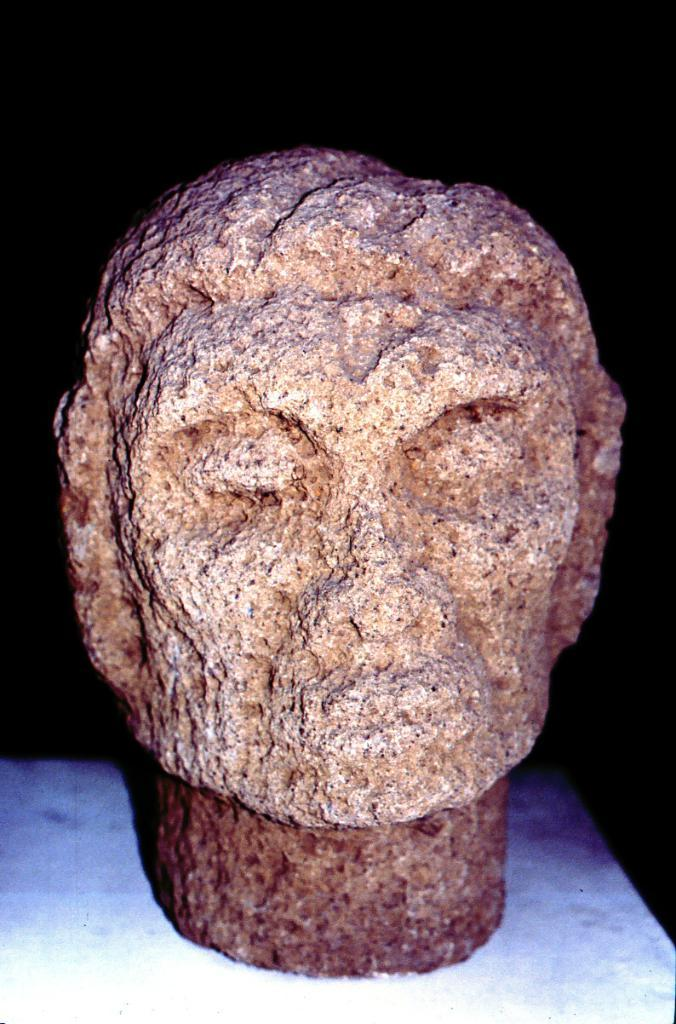What is the main subject of the image? The main subject of the image is a statue. What material is the statue made of? The statue is carved on stone. What is the statue placed on? The statue is placed on a white object. How would you describe the background of the image? The background of the image is dark. What shape are the eggs in the image? There are no eggs present in the image. How many potatoes can be seen in the image? There are no potatoes present in the image. 